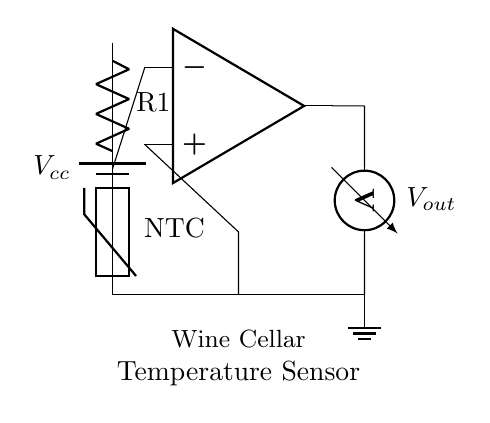What is the purpose of the thermistor in this circuit? The thermistor, labeled as "NTC," is used for temperature sensing. It changes its resistance with temperature, enabling the circuit to monitor the wine cellar's temperature.
Answer: Temperature sensing What type of resistor is used in this circuit? The resistor labeled as "R1" is a standard resistor, though its value is not specified in the diagram. It's part of a voltage divider configuration with the thermistor.
Answer: Standard resistor How many op-amps are present in this circuit? There is one op-amp indicated in the diagram, used for signal amplification. The op-amp's configuration is crucial for processing the voltage signal derived from the thermistor and resistor.
Answer: One What does the output voltage label represent? The output voltage, labeled as "Vout," represents the amplified signal that corresponds to the temperature sensed by the thermistor. It is taken from the op-amp output for monitoring purposes.
Answer: Amplified signal What type of circuit is this? This is an analog circuit designed for temperature monitoring. It utilizes continuous voltage levels to represent temperature variations, instead of discrete digital values.
Answer: Analog circuit What is the configuration of the thermistor in the circuit? The thermistor is part of a voltage divider configuration with R1, where the two components are connected in series to create a varying voltage that reflects changing temperatures.
Answer: Voltage divider 